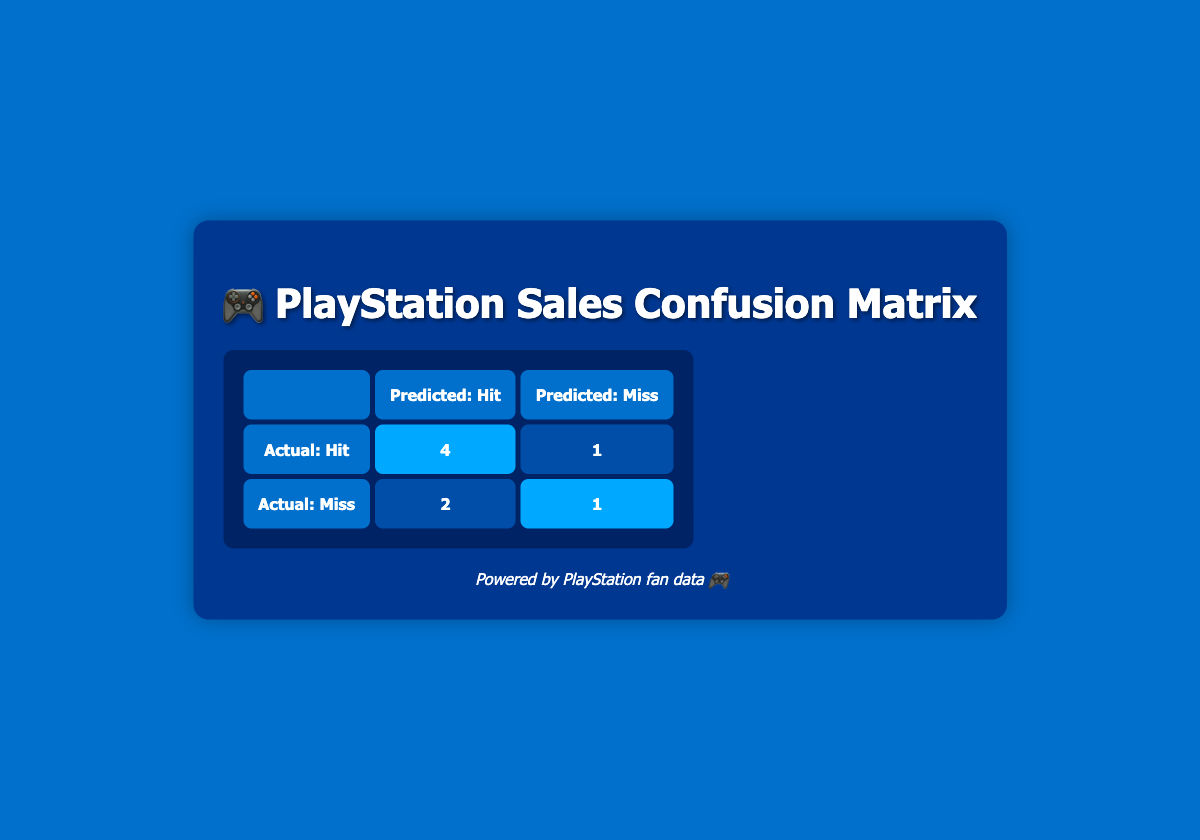What is the total number of games that were predicted to be a hit and actually turned out to be a hit? According to the table, there are 4 games that were both predicted and actually hits (highlighted as 4 in the table). Therefore, the total is 4.
Answer: 4 How many games were predicted to be a miss but were actually hits? In the table, it shows that 1 game was predicted to be a miss but actually turned out to be a hit (1 in the table). Thus, the answer is 1.
Answer: 1 What is the total number of games that were actually misses? From the table, the sum of games that were predicted to be misses and actually turned out to be misses is 1. Adding the ones that were predicted as hits but were misses (2), gives a total of 3.
Answer: 3 Was "The Last of Us Part II" accurately predicted? "The Last of Us Part II" had predicted sales of 4.0 but actual sales were 3.5, meaning that the prediction was incorrect. Thus, the answer is No.
Answer: No Which game had the highest actual sales? By looking at the table, "Spider-Man: Miles Morales" has the highest actual sales, which are 6.0. Thus, the answer is "Spider-Man: Miles Morales".
Answer: Spider-Man: Miles Morales What is the difference in predicted sales and actual sales for "Demon's Souls"? "Demon's Souls" has predicted sales of 1.5 and actual sales of 2.0. The difference is calculated as 2.0 - 1.5 = 0.5.
Answer: 0.5 How many games were both predicted and actually misses? The table indicates that 1 game was both predicted and actually a miss (highlighted in the table). Thus, the total is 1.
Answer: 1 What is the overall accuracy of the predictions? To find the accuracy, we take the total number of correct predictions (4 hits + 2 misses = 6) and divide by the total number of predictions (8), giving an accuracy of 6/8 = 0.75 or 75%.
Answer: 75% What proportion of the predicted hits turned out to be misses? Out of the 4 predicted hits, 1 turned out to be a miss. Thus, the proportion is 1 out of 4, which simplifies to 1/4 or 0.25.
Answer: 0.25 